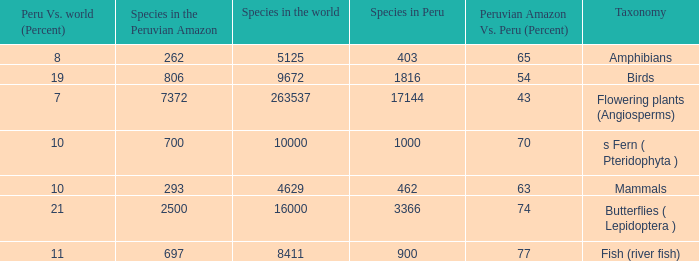What's the minimum species in the peruvian amazon with peru vs. world (percent) value of 7 7372.0. 